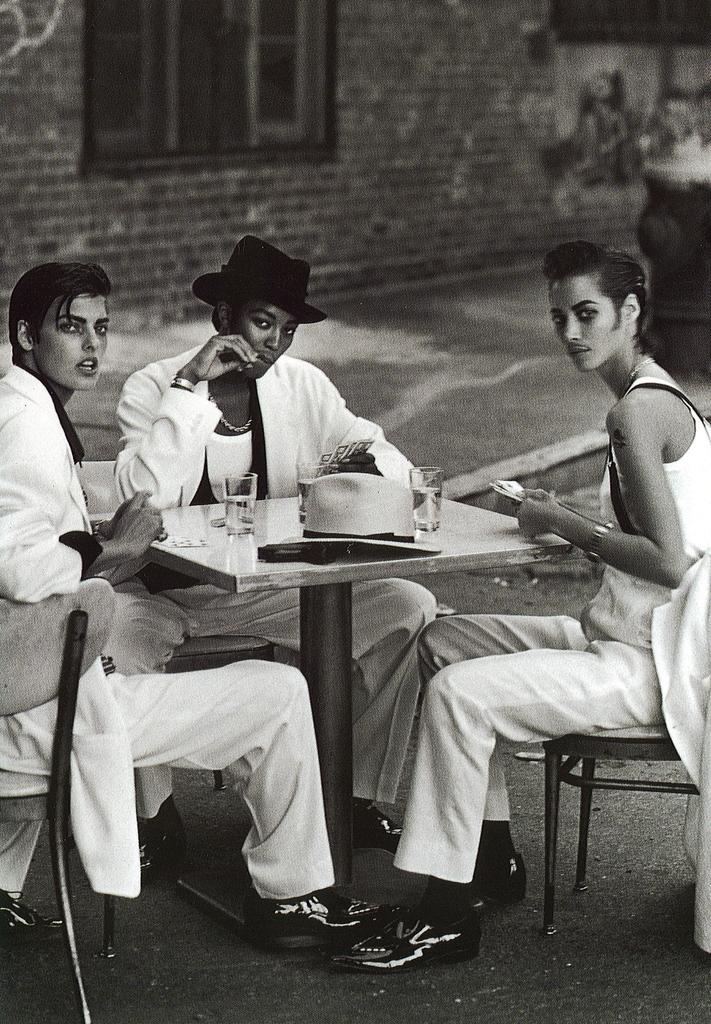How many people are sitting in the chairs in the image? There are three people sitting on chairs in the image. What is on the table in the image? There is a glass and a hat on the table in the image. What can be seen in the background of the image? There is a building visible in the background. Is the honey dripping from the hat in the image? There is no honey present in the image, so it cannot be dripping from the hat. 